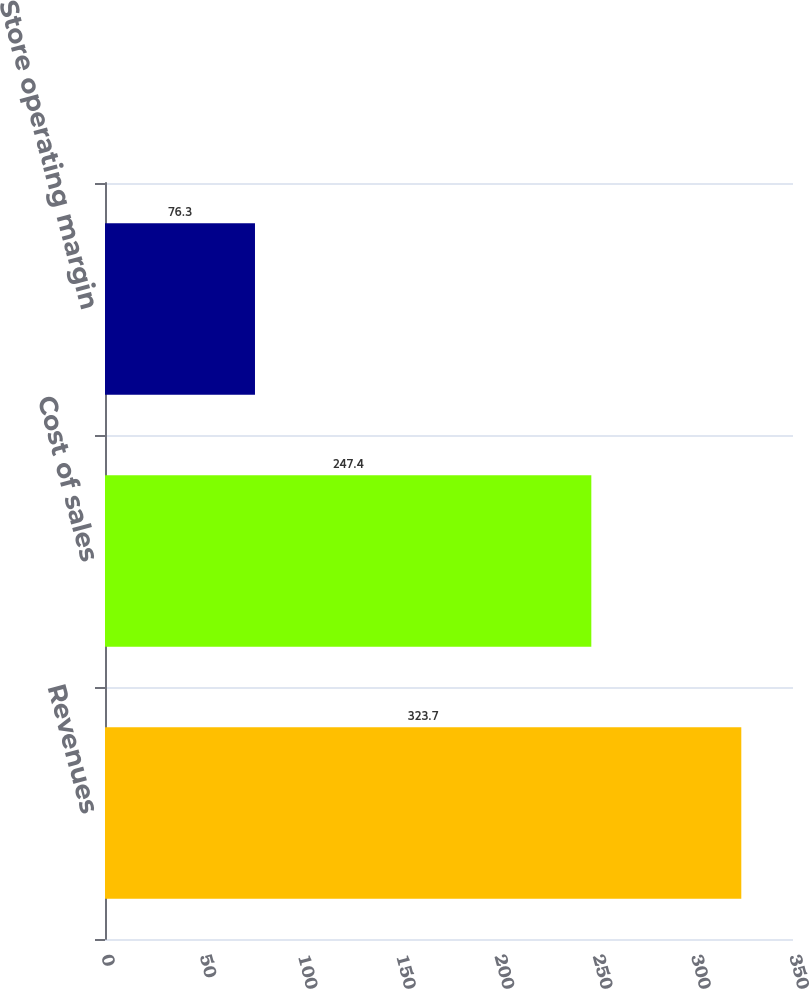Convert chart. <chart><loc_0><loc_0><loc_500><loc_500><bar_chart><fcel>Revenues<fcel>Cost of sales<fcel>Store operating margin<nl><fcel>323.7<fcel>247.4<fcel>76.3<nl></chart> 